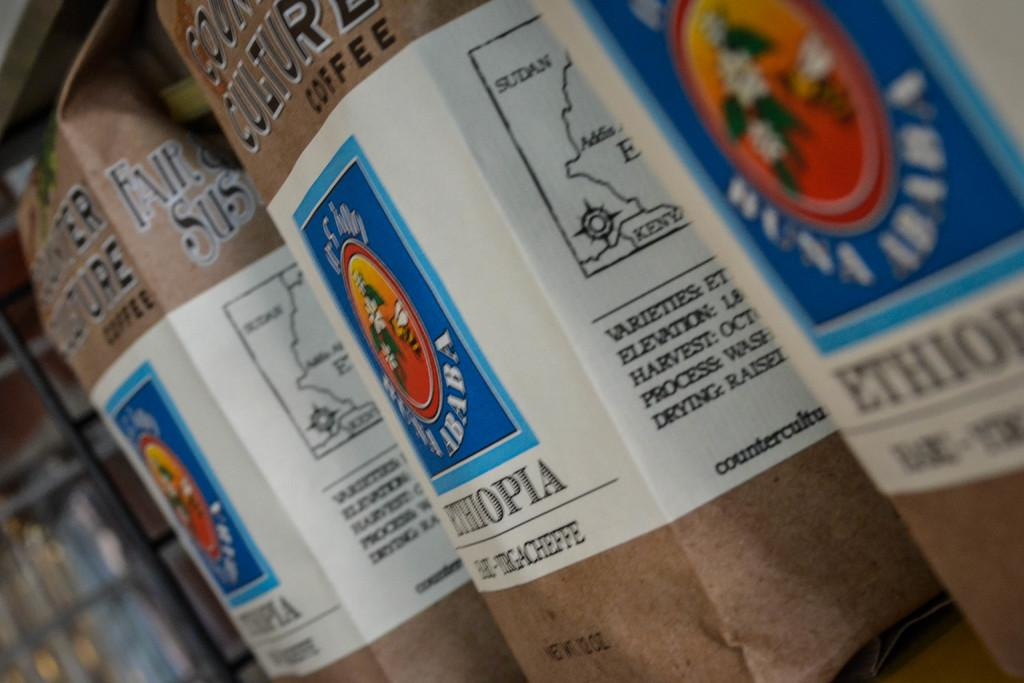Provide a one-sentence caption for the provided image. bags of substance that have coffee from ethiopia. 